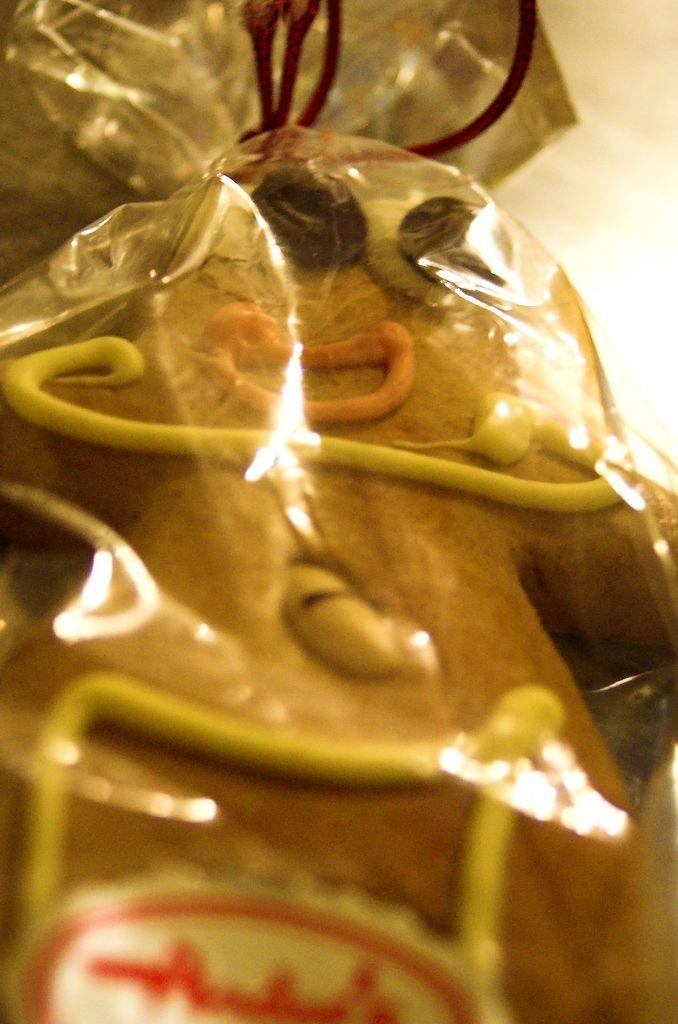What objects are present in the image? There are plastic covers in the image. What can be found inside the plastic covers? There are cookies inside the plastic covers. What type of beetle can be seen crawling on the dirt in the image? There is no beetle or dirt present in the image; it only features plastic covers with cookies inside. 